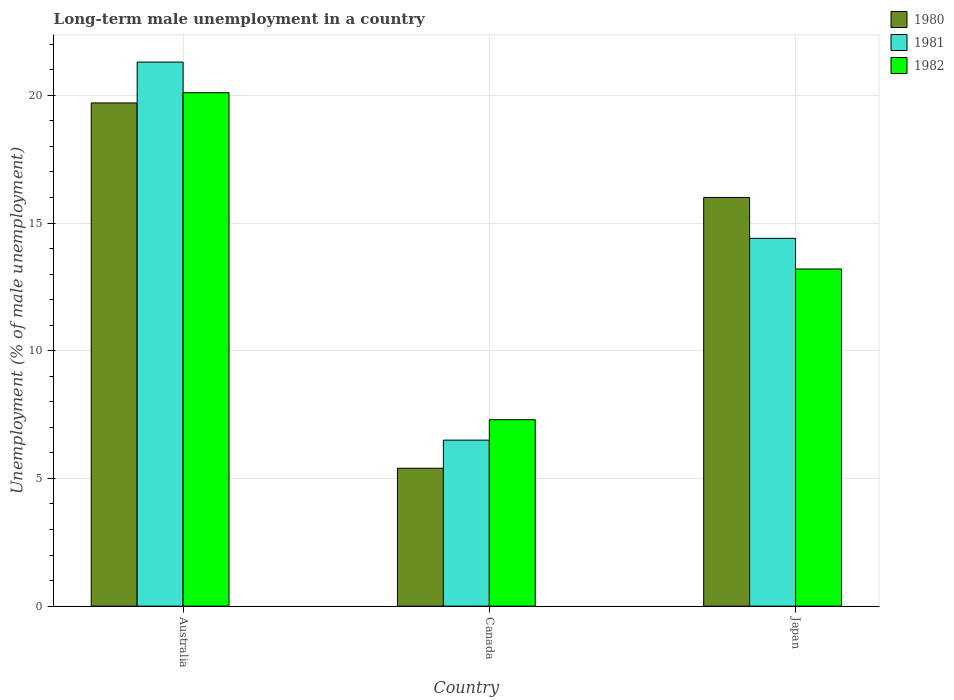How many different coloured bars are there?
Offer a terse response. 3. Are the number of bars per tick equal to the number of legend labels?
Offer a terse response. Yes. What is the label of the 3rd group of bars from the left?
Offer a very short reply. Japan. What is the percentage of long-term unemployed male population in 1980 in Japan?
Ensure brevity in your answer.  16. Across all countries, what is the maximum percentage of long-term unemployed male population in 1981?
Provide a short and direct response. 21.3. Across all countries, what is the minimum percentage of long-term unemployed male population in 1982?
Your answer should be very brief. 7.3. In which country was the percentage of long-term unemployed male population in 1980 maximum?
Keep it short and to the point. Australia. What is the total percentage of long-term unemployed male population in 1982 in the graph?
Your answer should be compact. 40.6. What is the difference between the percentage of long-term unemployed male population in 1982 in Australia and that in Canada?
Your answer should be compact. 12.8. What is the difference between the percentage of long-term unemployed male population in 1982 in Canada and the percentage of long-term unemployed male population in 1981 in Australia?
Your response must be concise. -14. What is the average percentage of long-term unemployed male population in 1982 per country?
Make the answer very short. 13.53. What is the difference between the percentage of long-term unemployed male population of/in 1980 and percentage of long-term unemployed male population of/in 1981 in Japan?
Provide a succinct answer. 1.6. In how many countries, is the percentage of long-term unemployed male population in 1982 greater than 16 %?
Keep it short and to the point. 1. What is the ratio of the percentage of long-term unemployed male population in 1982 in Australia to that in Canada?
Your response must be concise. 2.75. What is the difference between the highest and the second highest percentage of long-term unemployed male population in 1982?
Your answer should be compact. 6.9. What is the difference between the highest and the lowest percentage of long-term unemployed male population in 1982?
Keep it short and to the point. 12.8. In how many countries, is the percentage of long-term unemployed male population in 1980 greater than the average percentage of long-term unemployed male population in 1980 taken over all countries?
Give a very brief answer. 2. What does the 2nd bar from the right in Canada represents?
Give a very brief answer. 1981. Is it the case that in every country, the sum of the percentage of long-term unemployed male population in 1982 and percentage of long-term unemployed male population in 1981 is greater than the percentage of long-term unemployed male population in 1980?
Offer a very short reply. Yes. Does the graph contain any zero values?
Keep it short and to the point. No. Where does the legend appear in the graph?
Your answer should be compact. Top right. How many legend labels are there?
Make the answer very short. 3. How are the legend labels stacked?
Make the answer very short. Vertical. What is the title of the graph?
Ensure brevity in your answer.  Long-term male unemployment in a country. What is the label or title of the Y-axis?
Keep it short and to the point. Unemployment (% of male unemployment). What is the Unemployment (% of male unemployment) in 1980 in Australia?
Keep it short and to the point. 19.7. What is the Unemployment (% of male unemployment) of 1981 in Australia?
Ensure brevity in your answer.  21.3. What is the Unemployment (% of male unemployment) in 1982 in Australia?
Ensure brevity in your answer.  20.1. What is the Unemployment (% of male unemployment) of 1980 in Canada?
Your response must be concise. 5.4. What is the Unemployment (% of male unemployment) in 1981 in Canada?
Offer a terse response. 6.5. What is the Unemployment (% of male unemployment) in 1982 in Canada?
Your response must be concise. 7.3. What is the Unemployment (% of male unemployment) of 1980 in Japan?
Offer a very short reply. 16. What is the Unemployment (% of male unemployment) in 1981 in Japan?
Keep it short and to the point. 14.4. What is the Unemployment (% of male unemployment) of 1982 in Japan?
Keep it short and to the point. 13.2. Across all countries, what is the maximum Unemployment (% of male unemployment) in 1980?
Provide a short and direct response. 19.7. Across all countries, what is the maximum Unemployment (% of male unemployment) of 1981?
Provide a short and direct response. 21.3. Across all countries, what is the maximum Unemployment (% of male unemployment) in 1982?
Your answer should be compact. 20.1. Across all countries, what is the minimum Unemployment (% of male unemployment) in 1980?
Ensure brevity in your answer.  5.4. Across all countries, what is the minimum Unemployment (% of male unemployment) of 1981?
Your answer should be compact. 6.5. Across all countries, what is the minimum Unemployment (% of male unemployment) of 1982?
Your answer should be very brief. 7.3. What is the total Unemployment (% of male unemployment) in 1980 in the graph?
Your answer should be very brief. 41.1. What is the total Unemployment (% of male unemployment) in 1981 in the graph?
Your answer should be very brief. 42.2. What is the total Unemployment (% of male unemployment) of 1982 in the graph?
Make the answer very short. 40.6. What is the difference between the Unemployment (% of male unemployment) of 1982 in Australia and that in Japan?
Keep it short and to the point. 6.9. What is the difference between the Unemployment (% of male unemployment) of 1980 in Canada and that in Japan?
Ensure brevity in your answer.  -10.6. What is the difference between the Unemployment (% of male unemployment) in 1980 in Australia and the Unemployment (% of male unemployment) in 1981 in Canada?
Give a very brief answer. 13.2. What is the difference between the Unemployment (% of male unemployment) in 1980 in Australia and the Unemployment (% of male unemployment) in 1982 in Canada?
Your response must be concise. 12.4. What is the difference between the Unemployment (% of male unemployment) of 1981 in Australia and the Unemployment (% of male unemployment) of 1982 in Canada?
Your response must be concise. 14. What is the difference between the Unemployment (% of male unemployment) of 1980 in Australia and the Unemployment (% of male unemployment) of 1981 in Japan?
Your response must be concise. 5.3. What is the difference between the Unemployment (% of male unemployment) of 1981 in Australia and the Unemployment (% of male unemployment) of 1982 in Japan?
Your response must be concise. 8.1. What is the difference between the Unemployment (% of male unemployment) of 1980 in Canada and the Unemployment (% of male unemployment) of 1982 in Japan?
Provide a short and direct response. -7.8. What is the average Unemployment (% of male unemployment) in 1981 per country?
Ensure brevity in your answer.  14.07. What is the average Unemployment (% of male unemployment) of 1982 per country?
Give a very brief answer. 13.53. What is the difference between the Unemployment (% of male unemployment) of 1980 and Unemployment (% of male unemployment) of 1981 in Australia?
Provide a succinct answer. -1.6. What is the difference between the Unemployment (% of male unemployment) in 1981 and Unemployment (% of male unemployment) in 1982 in Australia?
Your answer should be compact. 1.2. What is the difference between the Unemployment (% of male unemployment) in 1980 and Unemployment (% of male unemployment) in 1981 in Japan?
Make the answer very short. 1.6. What is the difference between the Unemployment (% of male unemployment) in 1980 and Unemployment (% of male unemployment) in 1982 in Japan?
Your answer should be very brief. 2.8. What is the difference between the Unemployment (% of male unemployment) of 1981 and Unemployment (% of male unemployment) of 1982 in Japan?
Provide a short and direct response. 1.2. What is the ratio of the Unemployment (% of male unemployment) in 1980 in Australia to that in Canada?
Make the answer very short. 3.65. What is the ratio of the Unemployment (% of male unemployment) of 1981 in Australia to that in Canada?
Make the answer very short. 3.28. What is the ratio of the Unemployment (% of male unemployment) of 1982 in Australia to that in Canada?
Your answer should be compact. 2.75. What is the ratio of the Unemployment (% of male unemployment) in 1980 in Australia to that in Japan?
Give a very brief answer. 1.23. What is the ratio of the Unemployment (% of male unemployment) in 1981 in Australia to that in Japan?
Give a very brief answer. 1.48. What is the ratio of the Unemployment (% of male unemployment) in 1982 in Australia to that in Japan?
Offer a very short reply. 1.52. What is the ratio of the Unemployment (% of male unemployment) in 1980 in Canada to that in Japan?
Offer a terse response. 0.34. What is the ratio of the Unemployment (% of male unemployment) in 1981 in Canada to that in Japan?
Offer a very short reply. 0.45. What is the ratio of the Unemployment (% of male unemployment) in 1982 in Canada to that in Japan?
Ensure brevity in your answer.  0.55. What is the difference between the highest and the second highest Unemployment (% of male unemployment) of 1982?
Your answer should be compact. 6.9. What is the difference between the highest and the lowest Unemployment (% of male unemployment) of 1982?
Provide a succinct answer. 12.8. 